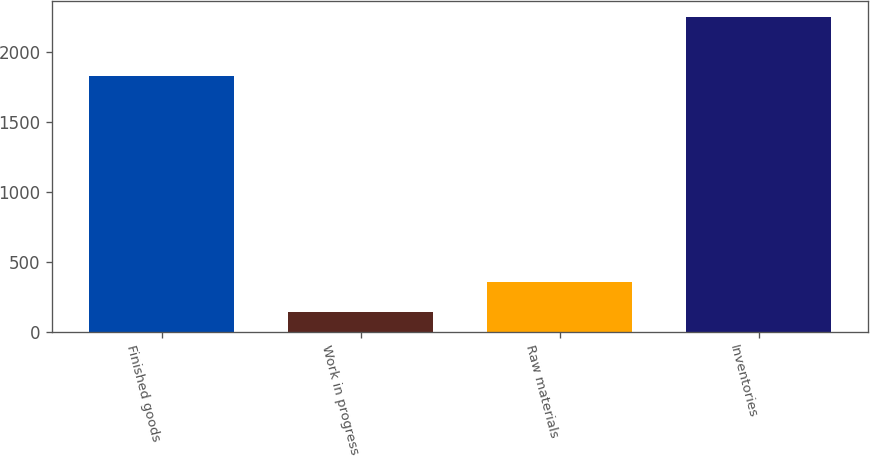Convert chart. <chart><loc_0><loc_0><loc_500><loc_500><bar_chart><fcel>Finished goods<fcel>Work in progress<fcel>Raw materials<fcel>Inventories<nl><fcel>1827.9<fcel>146.1<fcel>356.9<fcel>2254.1<nl></chart> 